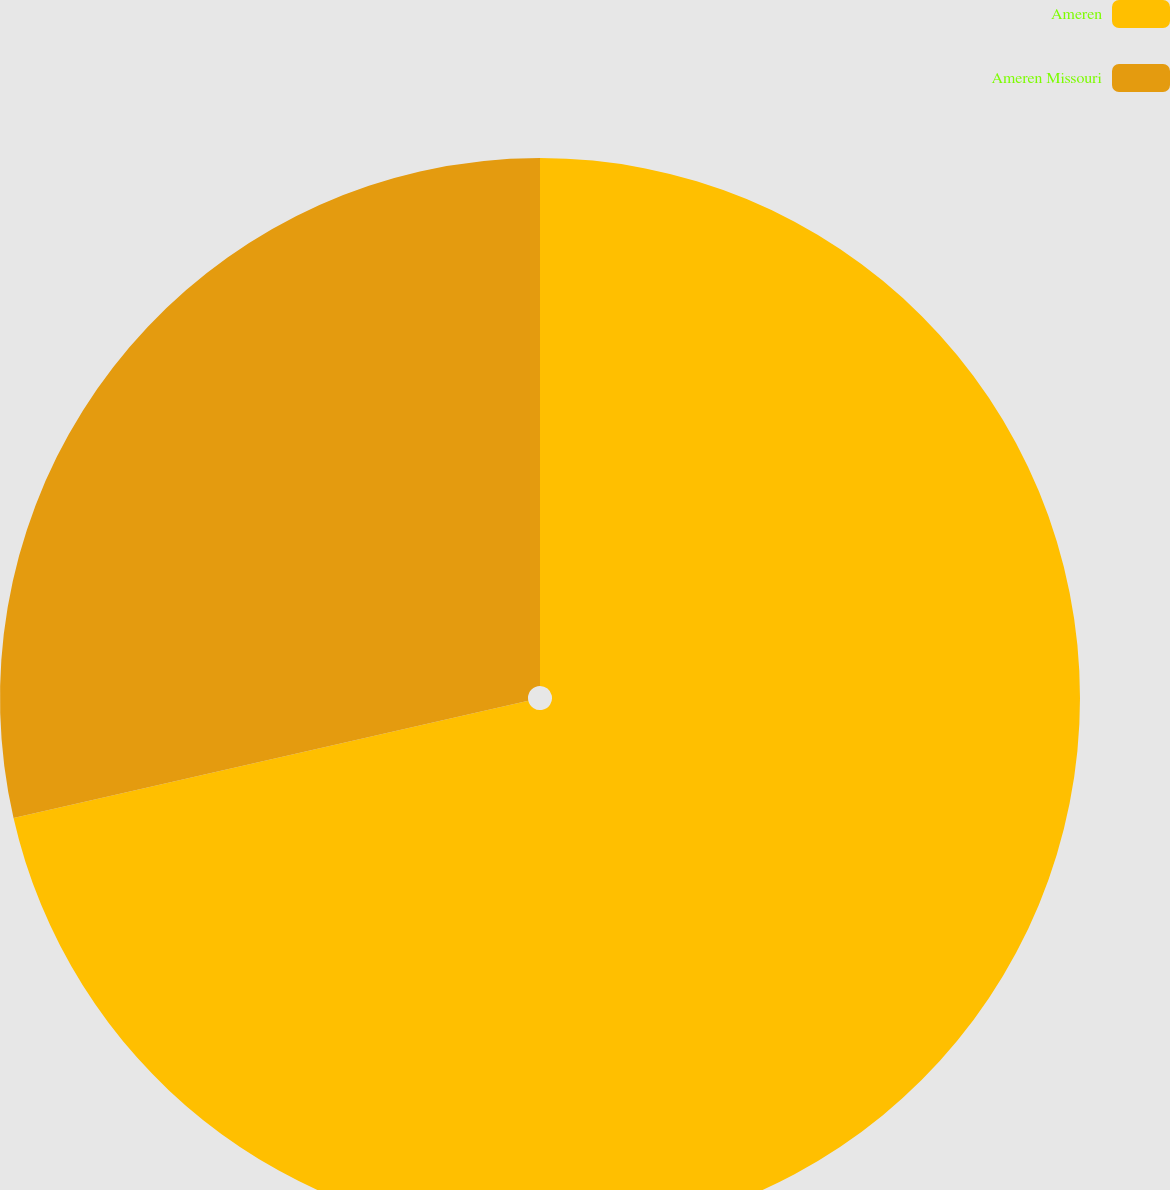Convert chart to OTSL. <chart><loc_0><loc_0><loc_500><loc_500><pie_chart><fcel>Ameren<fcel>Ameren Missouri<nl><fcel>71.43%<fcel>28.57%<nl></chart> 